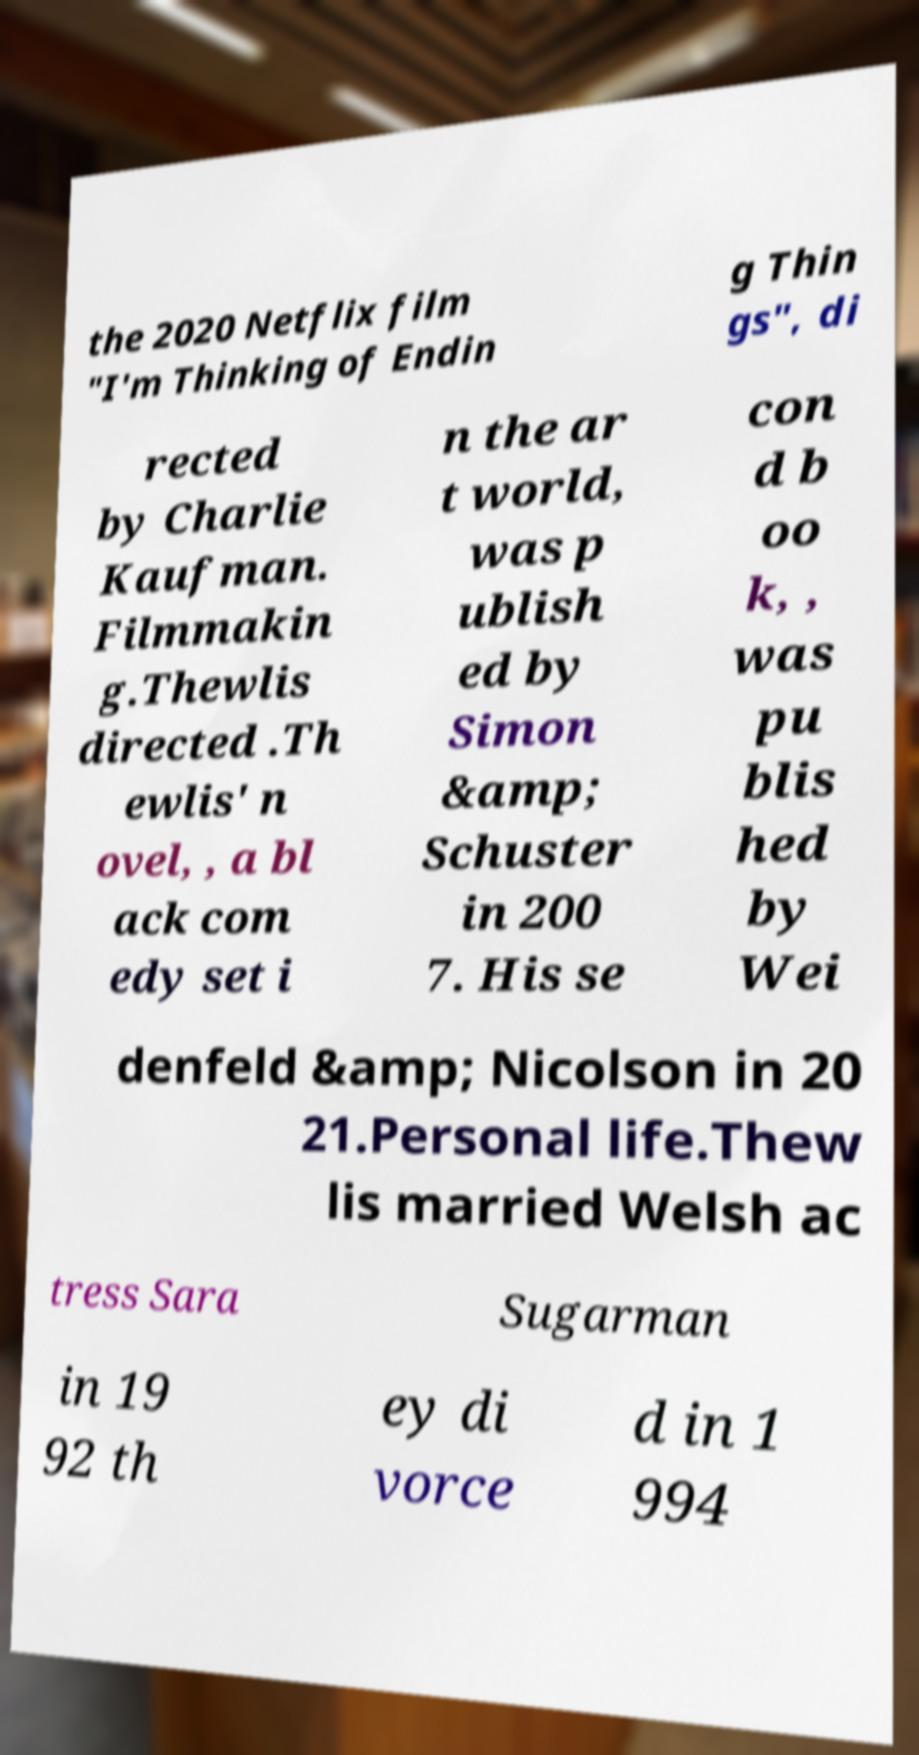Please identify and transcribe the text found in this image. the 2020 Netflix film "I'm Thinking of Endin g Thin gs", di rected by Charlie Kaufman. Filmmakin g.Thewlis directed .Th ewlis' n ovel, , a bl ack com edy set i n the ar t world, was p ublish ed by Simon &amp; Schuster in 200 7. His se con d b oo k, , was pu blis hed by Wei denfeld &amp; Nicolson in 20 21.Personal life.Thew lis married Welsh ac tress Sara Sugarman in 19 92 th ey di vorce d in 1 994 